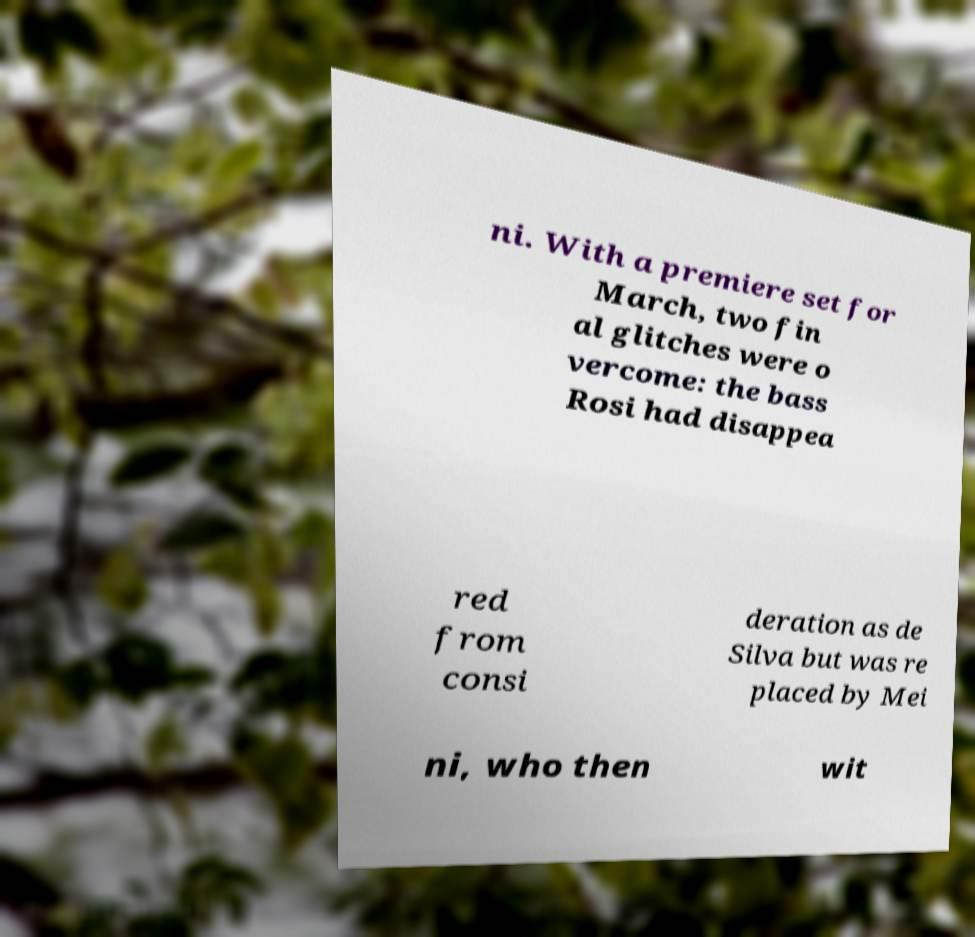What messages or text are displayed in this image? I need them in a readable, typed format. ni. With a premiere set for March, two fin al glitches were o vercome: the bass Rosi had disappea red from consi deration as de Silva but was re placed by Mei ni, who then wit 